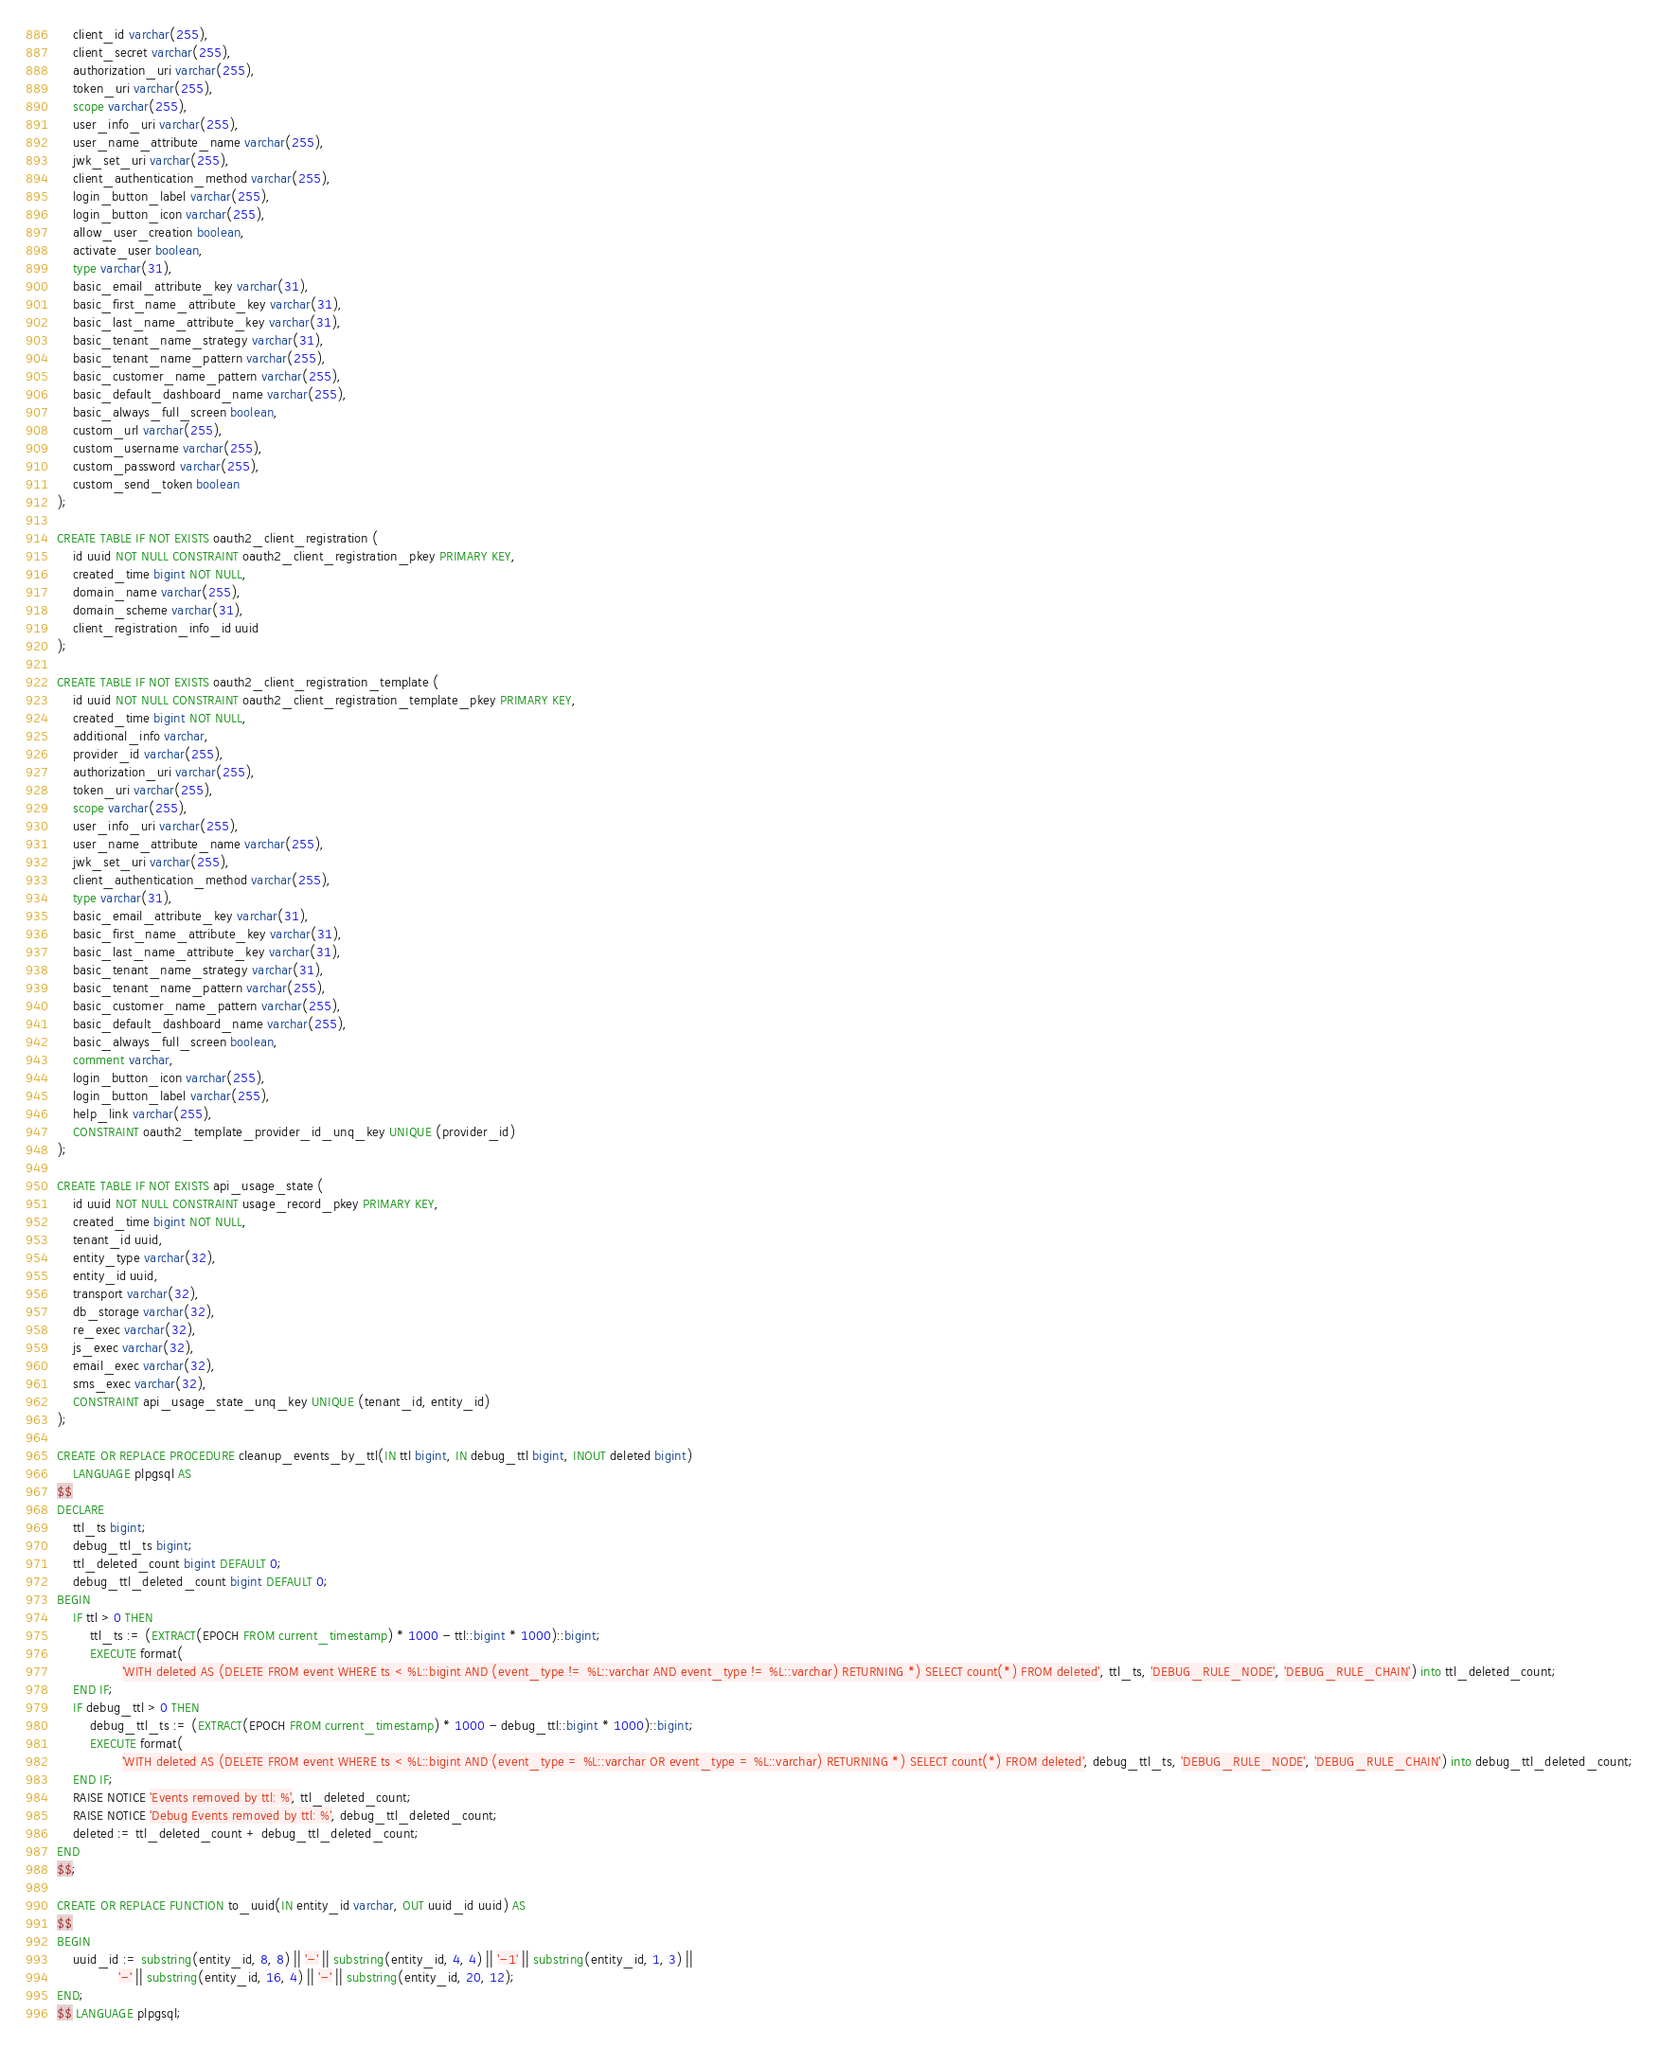<code> <loc_0><loc_0><loc_500><loc_500><_SQL_>    client_id varchar(255),
    client_secret varchar(255),
    authorization_uri varchar(255),
    token_uri varchar(255),
    scope varchar(255),
    user_info_uri varchar(255),
    user_name_attribute_name varchar(255),
    jwk_set_uri varchar(255),
    client_authentication_method varchar(255),
    login_button_label varchar(255),
    login_button_icon varchar(255),
    allow_user_creation boolean,
    activate_user boolean,
    type varchar(31),
    basic_email_attribute_key varchar(31),
    basic_first_name_attribute_key varchar(31),
    basic_last_name_attribute_key varchar(31),
    basic_tenant_name_strategy varchar(31),
    basic_tenant_name_pattern varchar(255),
    basic_customer_name_pattern varchar(255),
    basic_default_dashboard_name varchar(255),
    basic_always_full_screen boolean,
    custom_url varchar(255),
    custom_username varchar(255),
    custom_password varchar(255),
    custom_send_token boolean
);

CREATE TABLE IF NOT EXISTS oauth2_client_registration (
    id uuid NOT NULL CONSTRAINT oauth2_client_registration_pkey PRIMARY KEY,
    created_time bigint NOT NULL,
    domain_name varchar(255),
    domain_scheme varchar(31),
    client_registration_info_id uuid
);

CREATE TABLE IF NOT EXISTS oauth2_client_registration_template (
    id uuid NOT NULL CONSTRAINT oauth2_client_registration_template_pkey PRIMARY KEY,
    created_time bigint NOT NULL,
    additional_info varchar,
    provider_id varchar(255),
    authorization_uri varchar(255),
    token_uri varchar(255),
    scope varchar(255),
    user_info_uri varchar(255),
    user_name_attribute_name varchar(255),
    jwk_set_uri varchar(255),
    client_authentication_method varchar(255),
    type varchar(31),
    basic_email_attribute_key varchar(31),
    basic_first_name_attribute_key varchar(31),
    basic_last_name_attribute_key varchar(31),
    basic_tenant_name_strategy varchar(31),
    basic_tenant_name_pattern varchar(255),
    basic_customer_name_pattern varchar(255),
    basic_default_dashboard_name varchar(255),
    basic_always_full_screen boolean,
    comment varchar,
    login_button_icon varchar(255),
    login_button_label varchar(255),
    help_link varchar(255),
    CONSTRAINT oauth2_template_provider_id_unq_key UNIQUE (provider_id)
);

CREATE TABLE IF NOT EXISTS api_usage_state (
    id uuid NOT NULL CONSTRAINT usage_record_pkey PRIMARY KEY,
    created_time bigint NOT NULL,
    tenant_id uuid,
    entity_type varchar(32),
    entity_id uuid,
    transport varchar(32),
    db_storage varchar(32),
    re_exec varchar(32),
    js_exec varchar(32),
    email_exec varchar(32),
    sms_exec varchar(32),
    CONSTRAINT api_usage_state_unq_key UNIQUE (tenant_id, entity_id)
);

CREATE OR REPLACE PROCEDURE cleanup_events_by_ttl(IN ttl bigint, IN debug_ttl bigint, INOUT deleted bigint)
    LANGUAGE plpgsql AS
$$
DECLARE
    ttl_ts bigint;
    debug_ttl_ts bigint;
    ttl_deleted_count bigint DEFAULT 0;
    debug_ttl_deleted_count bigint DEFAULT 0;
BEGIN
    IF ttl > 0 THEN
        ttl_ts := (EXTRACT(EPOCH FROM current_timestamp) * 1000 - ttl::bigint * 1000)::bigint;
        EXECUTE format(
                'WITH deleted AS (DELETE FROM event WHERE ts < %L::bigint AND (event_type != %L::varchar AND event_type != %L::varchar) RETURNING *) SELECT count(*) FROM deleted', ttl_ts, 'DEBUG_RULE_NODE', 'DEBUG_RULE_CHAIN') into ttl_deleted_count;
    END IF;
    IF debug_ttl > 0 THEN
        debug_ttl_ts := (EXTRACT(EPOCH FROM current_timestamp) * 1000 - debug_ttl::bigint * 1000)::bigint;
        EXECUTE format(
                'WITH deleted AS (DELETE FROM event WHERE ts < %L::bigint AND (event_type = %L::varchar OR event_type = %L::varchar) RETURNING *) SELECT count(*) FROM deleted', debug_ttl_ts, 'DEBUG_RULE_NODE', 'DEBUG_RULE_CHAIN') into debug_ttl_deleted_count;
    END IF;
    RAISE NOTICE 'Events removed by ttl: %', ttl_deleted_count;
    RAISE NOTICE 'Debug Events removed by ttl: %', debug_ttl_deleted_count;
    deleted := ttl_deleted_count + debug_ttl_deleted_count;
END
$$;

CREATE OR REPLACE FUNCTION to_uuid(IN entity_id varchar, OUT uuid_id uuid) AS
$$
BEGIN
    uuid_id := substring(entity_id, 8, 8) || '-' || substring(entity_id, 4, 4) || '-1' || substring(entity_id, 1, 3) ||
               '-' || substring(entity_id, 16, 4) || '-' || substring(entity_id, 20, 12);
END;
$$ LANGUAGE plpgsql;

</code> 